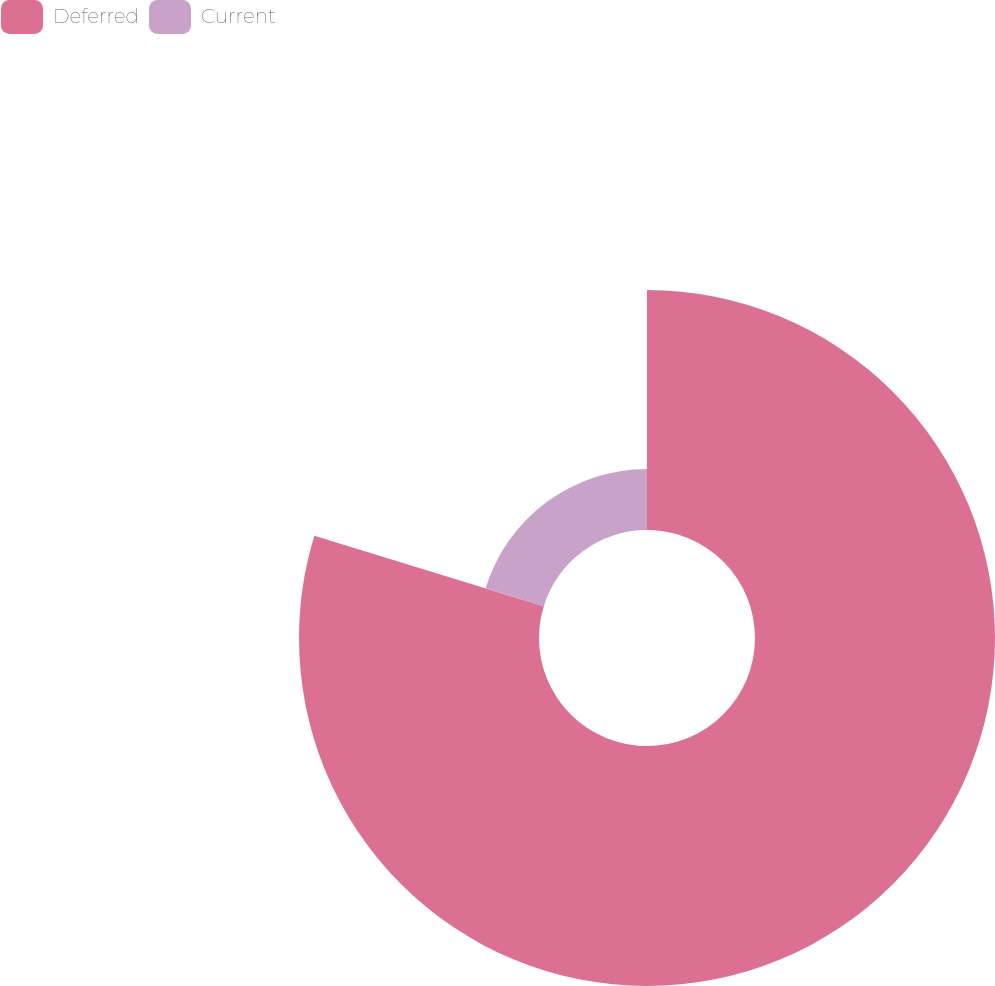<chart> <loc_0><loc_0><loc_500><loc_500><pie_chart><fcel>Deferred<fcel>Current<nl><fcel>79.75%<fcel>20.25%<nl></chart> 